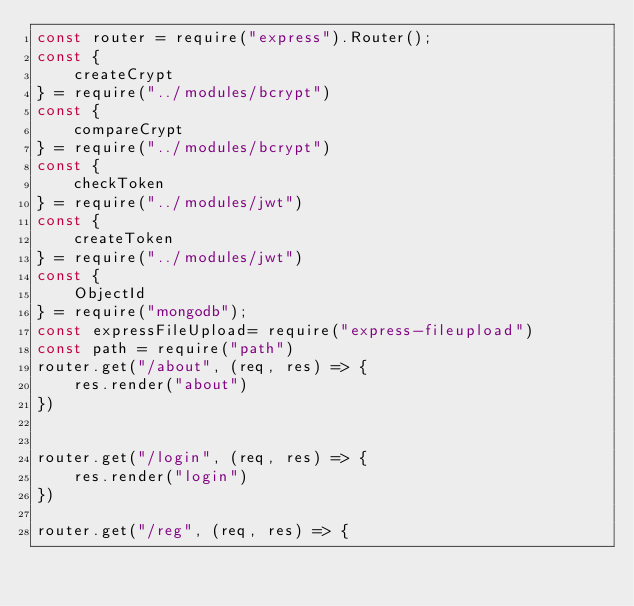Convert code to text. <code><loc_0><loc_0><loc_500><loc_500><_JavaScript_>const router = require("express").Router();
const {
    createCrypt
} = require("../modules/bcrypt")
const {
    compareCrypt
} = require("../modules/bcrypt")
const {
    checkToken
} = require("../modules/jwt")
const {
    createToken
} = require("../modules/jwt")
const {
    ObjectId
} = require("mongodb");
const expressFileUpload= require("express-fileupload")
const path = require("path")
router.get("/about", (req, res) => {
    res.render("about")
})


router.get("/login", (req, res) => {
    res.render("login")
})

router.get("/reg", (req, res) => {</code> 